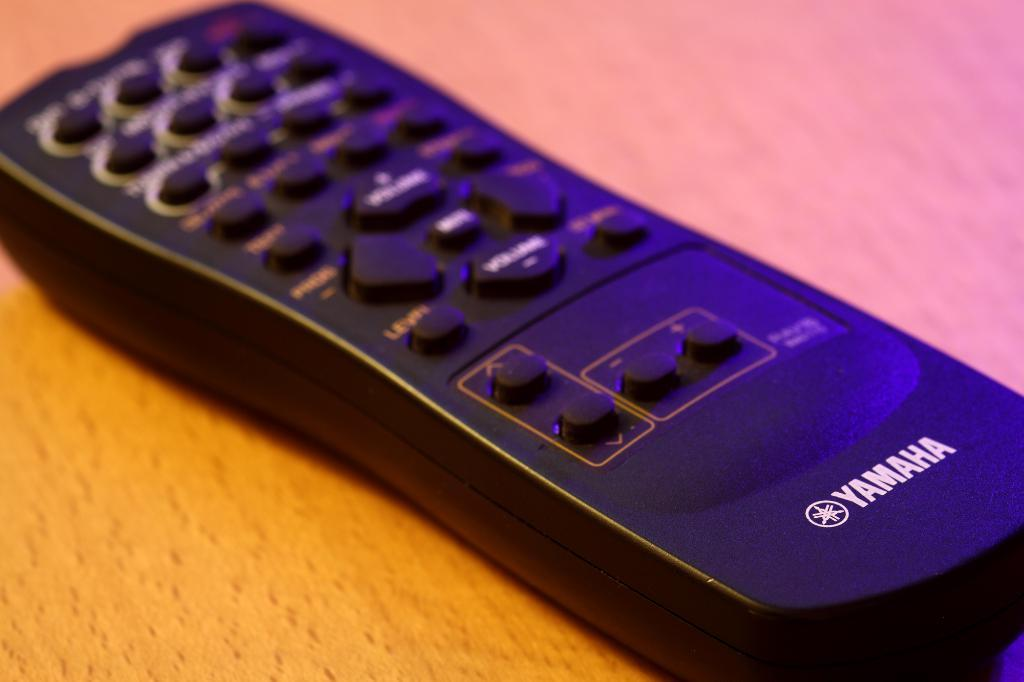<image>
Give a short and clear explanation of the subsequent image. A remote control for a Yamaha device sits on a table. 